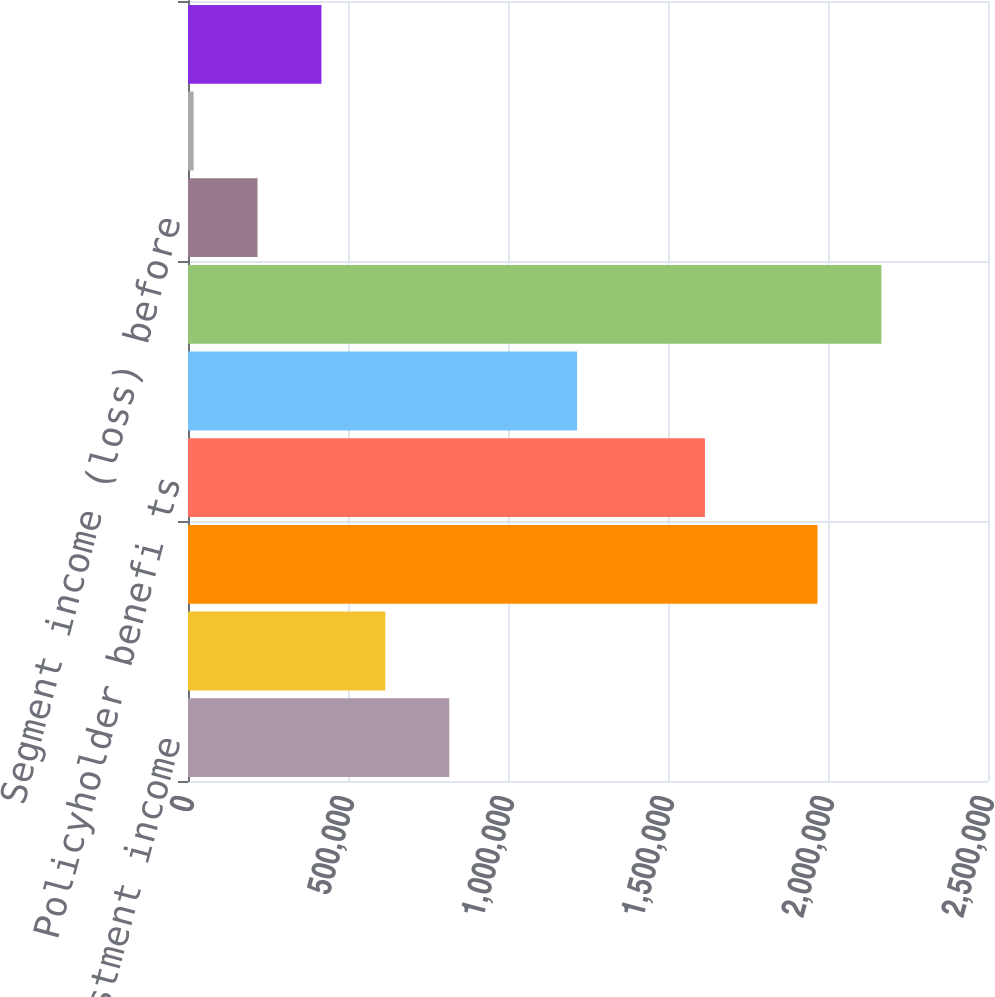Convert chart. <chart><loc_0><loc_0><loc_500><loc_500><bar_chart><fcel>Net investment income<fcel>Fees and other income<fcel>Total revenues<fcel>Policyholder benefi ts<fcel>Underwriting general and<fcel>Total benefits losses and<fcel>Segment income (loss) before<fcel>Provision (benefit) for income<fcel>Net income<nl><fcel>816438<fcel>616700<fcel>1.96716e+06<fcel>1.61539e+06<fcel>1.21592e+06<fcel>2.1669e+06<fcel>217222<fcel>17484<fcel>416961<nl></chart> 